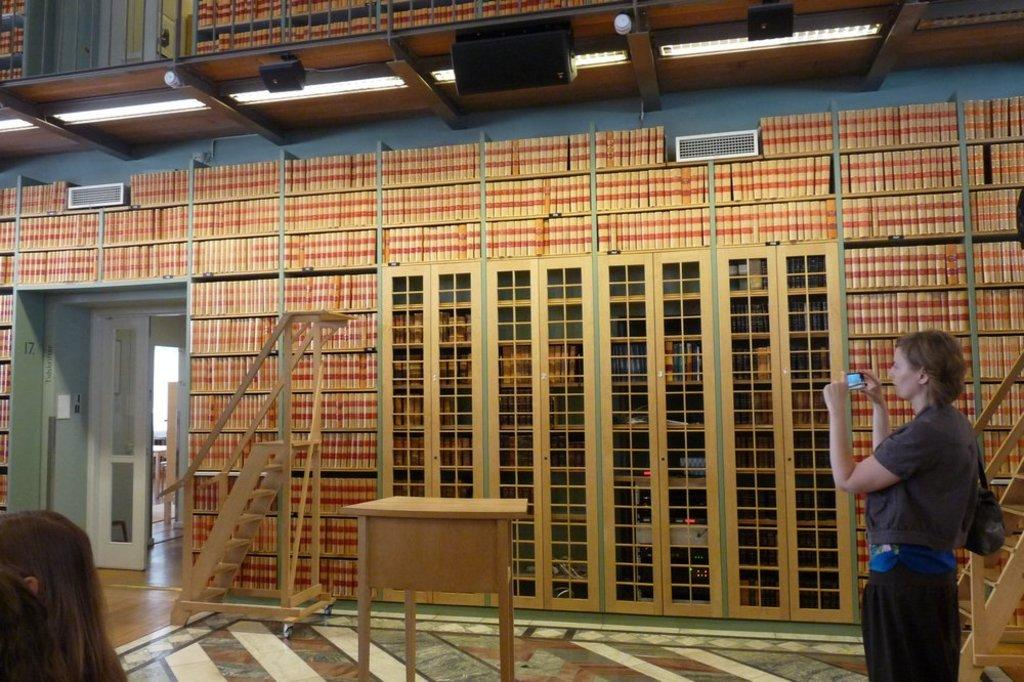What is the lady in the foreground of the image holding? The lady is holding a gadget in the foreground of the image. What can be seen in the background of the image? In the background of the image, there is a ladder, a desk, a door, lamps, and other objects. Can you describe the person located in the bottom left side of the image? There is a person in the bottom left side of the image, but no specific details about them are provided. What type of shirt is the thumb wearing in the image? There is no thumb or shirt present in the image. 